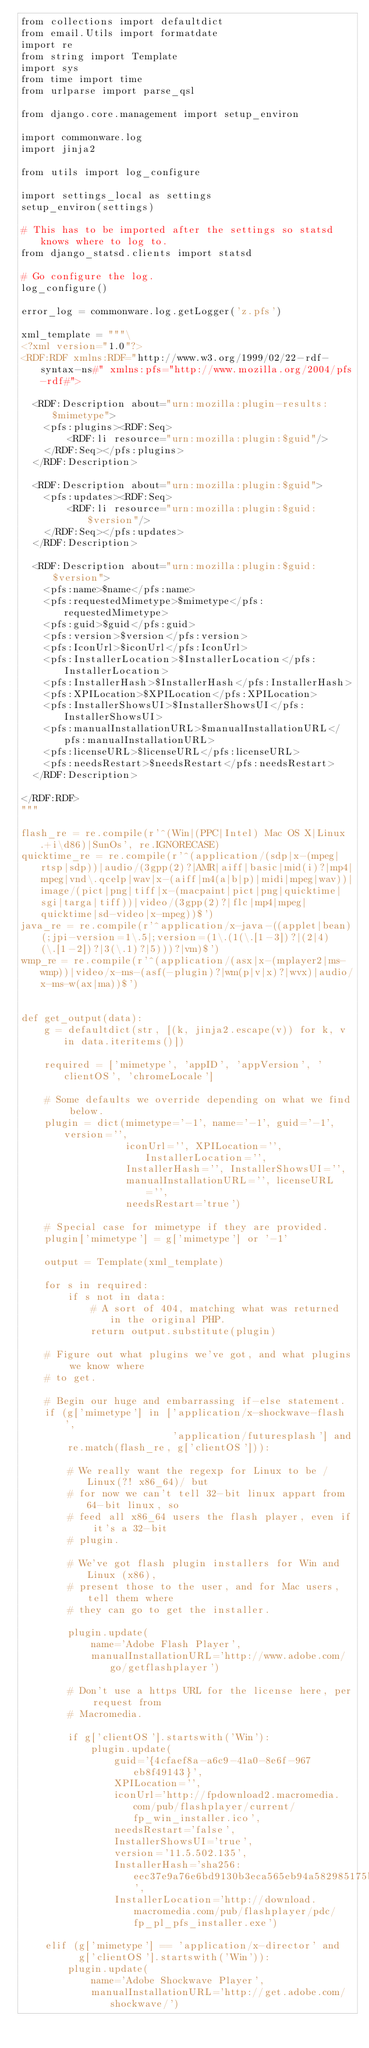Convert code to text. <code><loc_0><loc_0><loc_500><loc_500><_Python_>from collections import defaultdict
from email.Utils import formatdate
import re
from string import Template
import sys
from time import time
from urlparse import parse_qsl

from django.core.management import setup_environ

import commonware.log
import jinja2

from utils import log_configure

import settings_local as settings
setup_environ(settings)

# This has to be imported after the settings so statsd knows where to log to.
from django_statsd.clients import statsd

# Go configure the log.
log_configure()

error_log = commonware.log.getLogger('z.pfs')

xml_template = """\
<?xml version="1.0"?>
<RDF:RDF xmlns:RDF="http://www.w3.org/1999/02/22-rdf-syntax-ns#" xmlns:pfs="http://www.mozilla.org/2004/pfs-rdf#">

  <RDF:Description about="urn:mozilla:plugin-results:$mimetype">
    <pfs:plugins><RDF:Seq>
        <RDF:li resource="urn:mozilla:plugin:$guid"/>
    </RDF:Seq></pfs:plugins>
  </RDF:Description>

  <RDF:Description about="urn:mozilla:plugin:$guid">
    <pfs:updates><RDF:Seq>
        <RDF:li resource="urn:mozilla:plugin:$guid:$version"/>
    </RDF:Seq></pfs:updates>
  </RDF:Description>

  <RDF:Description about="urn:mozilla:plugin:$guid:$version">
    <pfs:name>$name</pfs:name>
    <pfs:requestedMimetype>$mimetype</pfs:requestedMimetype>
    <pfs:guid>$guid</pfs:guid>
    <pfs:version>$version</pfs:version>
    <pfs:IconUrl>$iconUrl</pfs:IconUrl>
    <pfs:InstallerLocation>$InstallerLocation</pfs:InstallerLocation>
    <pfs:InstallerHash>$InstallerHash</pfs:InstallerHash>
    <pfs:XPILocation>$XPILocation</pfs:XPILocation>
    <pfs:InstallerShowsUI>$InstallerShowsUI</pfs:InstallerShowsUI>
    <pfs:manualInstallationURL>$manualInstallationURL</pfs:manualInstallationURL>
    <pfs:licenseURL>$licenseURL</pfs:licenseURL>
    <pfs:needsRestart>$needsRestart</pfs:needsRestart>
  </RDF:Description>

</RDF:RDF>
"""

flash_re = re.compile(r'^(Win|(PPC|Intel) Mac OS X|Linux.+i\d86)|SunOs', re.IGNORECASE)
quicktime_re = re.compile(r'^(application/(sdp|x-(mpeg|rtsp|sdp))|audio/(3gpp(2)?|AMR|aiff|basic|mid(i)?|mp4|mpeg|vnd\.qcelp|wav|x-(aiff|m4(a|b|p)|midi|mpeg|wav))|image/(pict|png|tiff|x-(macpaint|pict|png|quicktime|sgi|targa|tiff))|video/(3gpp(2)?|flc|mp4|mpeg|quicktime|sd-video|x-mpeg))$')
java_re = re.compile(r'^application/x-java-((applet|bean)(;jpi-version=1\.5|;version=(1\.(1(\.[1-3])?|(2|4)(\.[1-2])?|3(\.1)?|5)))?|vm)$')
wmp_re = re.compile(r'^(application/(asx|x-(mplayer2|ms-wmp))|video/x-ms-(asf(-plugin)?|wm(p|v|x)?|wvx)|audio/x-ms-w(ax|ma))$')


def get_output(data):
    g = defaultdict(str, [(k, jinja2.escape(v)) for k, v in data.iteritems()])

    required = ['mimetype', 'appID', 'appVersion', 'clientOS', 'chromeLocale']

    # Some defaults we override depending on what we find below.
    plugin = dict(mimetype='-1', name='-1', guid='-1', version='',
                  iconUrl='', XPILocation='', InstallerLocation='',
                  InstallerHash='', InstallerShowsUI='',
                  manualInstallationURL='', licenseURL='',
                  needsRestart='true')

    # Special case for mimetype if they are provided.
    plugin['mimetype'] = g['mimetype'] or '-1'

    output = Template(xml_template)

    for s in required:
        if s not in data:
            # A sort of 404, matching what was returned in the original PHP.
            return output.substitute(plugin)

    # Figure out what plugins we've got, and what plugins we know where
    # to get.

    # Begin our huge and embarrassing if-else statement.
    if (g['mimetype'] in ['application/x-shockwave-flash',
                          'application/futuresplash'] and
        re.match(flash_re, g['clientOS'])):

        # We really want the regexp for Linux to be /Linux(?! x86_64)/ but
        # for now we can't tell 32-bit linux appart from 64-bit linux, so
        # feed all x86_64 users the flash player, even if it's a 32-bit
        # plugin.

        # We've got flash plugin installers for Win and Linux (x86),
        # present those to the user, and for Mac users, tell them where
        # they can go to get the installer.

        plugin.update(
            name='Adobe Flash Player',
            manualInstallationURL='http://www.adobe.com/go/getflashplayer')

        # Don't use a https URL for the license here, per request from
        # Macromedia.

        if g['clientOS'].startswith('Win'):
            plugin.update(
                guid='{4cfaef8a-a6c9-41a0-8e6f-967eb8f49143}',
                XPILocation='',
                iconUrl='http://fpdownload2.macromedia.com/pub/flashplayer/current/fp_win_installer.ico',
                needsRestart='false',
                InstallerShowsUI='true',
                version='11.5.502.135',
                InstallerHash='sha256:eec37e9a76e6bd9130b3eca565eb94a582985175ba9dff99795469de3cf09046',
                InstallerLocation='http://download.macromedia.com/pub/flashplayer/pdc/fp_pl_pfs_installer.exe')

    elif (g['mimetype'] == 'application/x-director' and
          g['clientOS'].startswith('Win')):
        plugin.update(
            name='Adobe Shockwave Player',
            manualInstallationURL='http://get.adobe.com/shockwave/')
</code> 